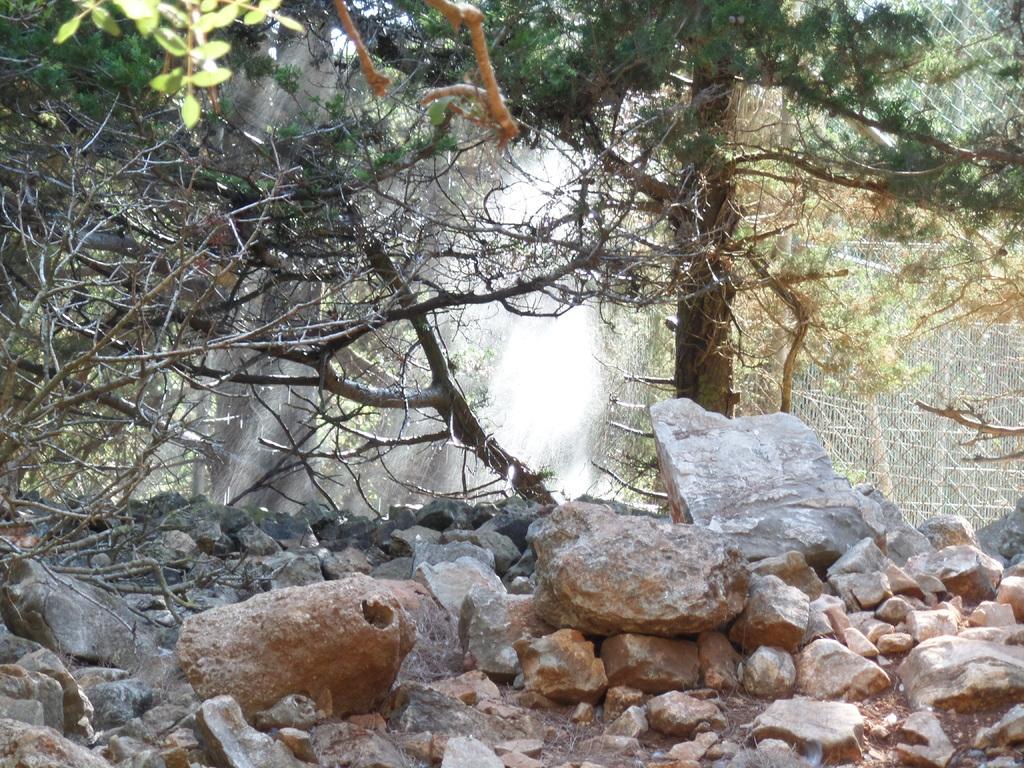Describe this image in one or two sentences. In this image we can see trees. At the bottom of the image, we can see rocks. On the right side of the image, we can see a mesh. 